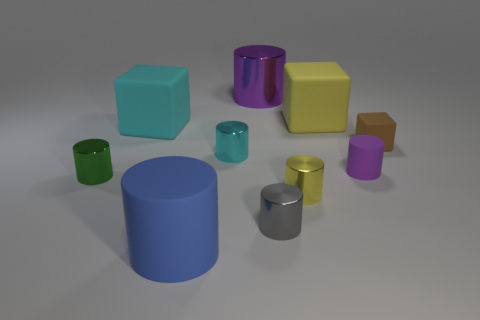Subtract all purple cylinders. How many were subtracted if there are1purple cylinders left? 1 Subtract all yellow blocks. How many blocks are left? 2 Subtract all large blocks. How many blocks are left? 1 Subtract 1 cylinders. How many cylinders are left? 6 Subtract all green cylinders. Subtract all green blocks. How many cylinders are left? 6 Subtract all red cylinders. How many brown blocks are left? 1 Subtract all purple matte cylinders. Subtract all brown things. How many objects are left? 8 Add 6 yellow rubber objects. How many yellow rubber objects are left? 7 Add 3 big blue matte objects. How many big blue matte objects exist? 4 Subtract 0 gray cubes. How many objects are left? 10 